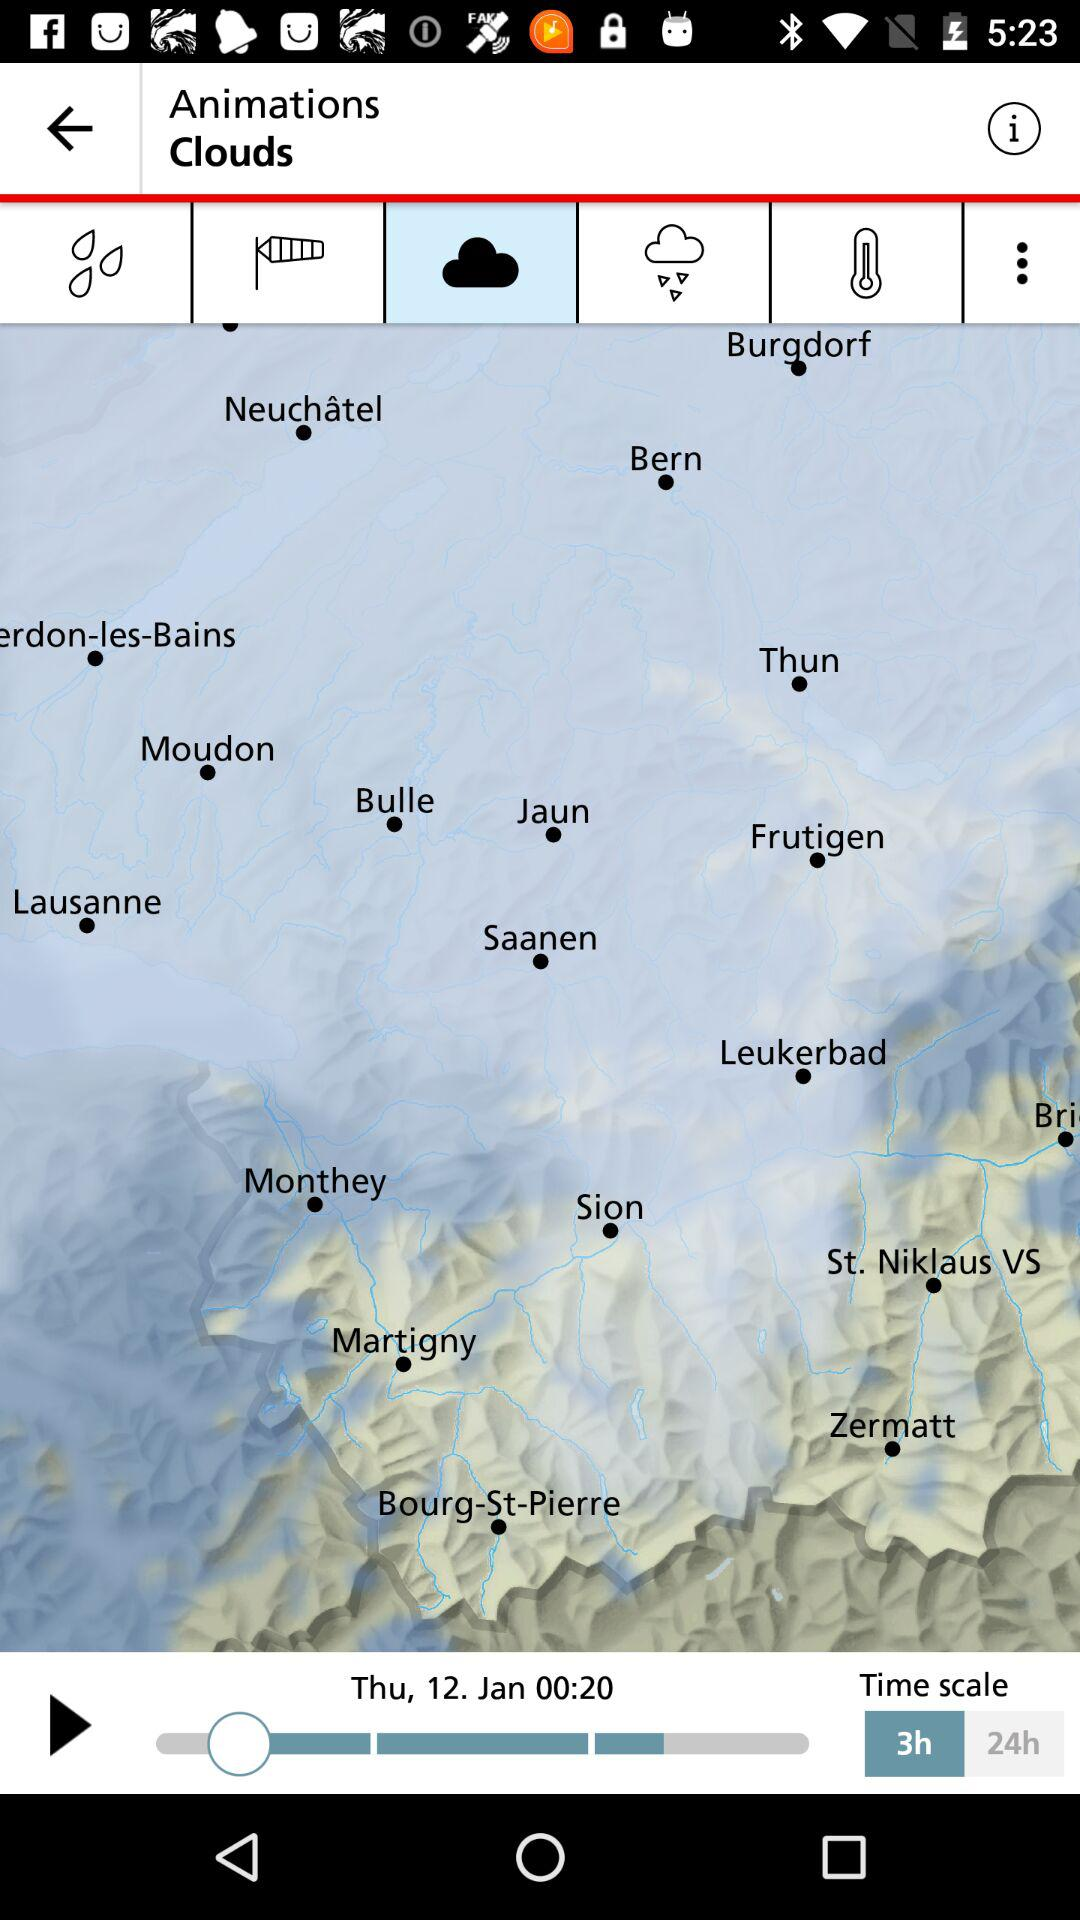What day is mentioned? The mentioned day is Thursday. 